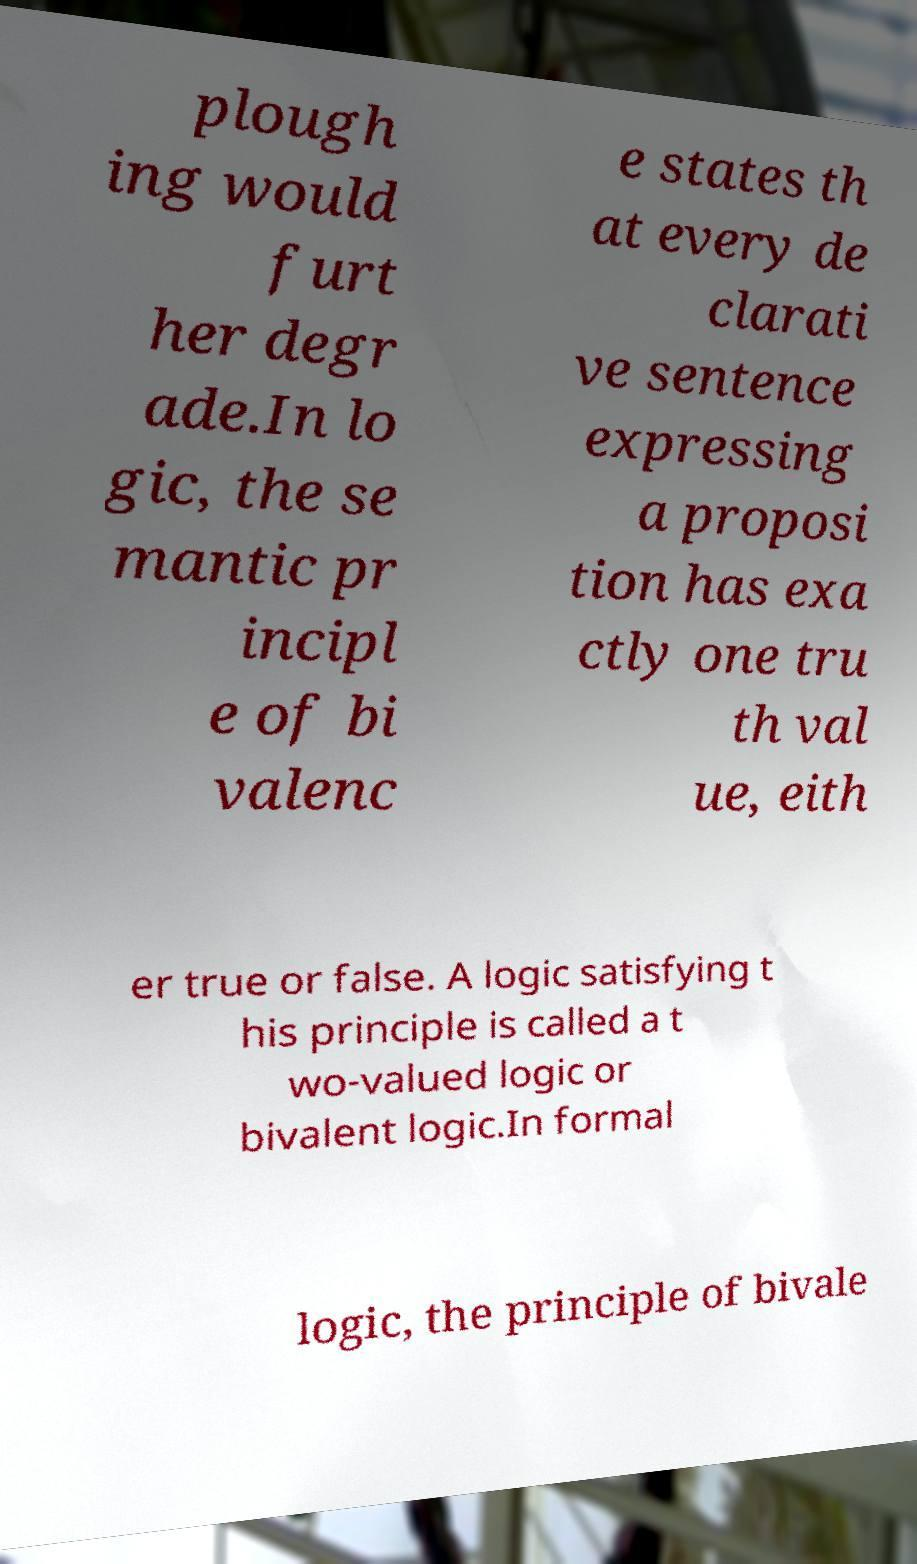Can you read and provide the text displayed in the image?This photo seems to have some interesting text. Can you extract and type it out for me? plough ing would furt her degr ade.In lo gic, the se mantic pr incipl e of bi valenc e states th at every de clarati ve sentence expressing a proposi tion has exa ctly one tru th val ue, eith er true or false. A logic satisfying t his principle is called a t wo-valued logic or bivalent logic.In formal logic, the principle of bivale 